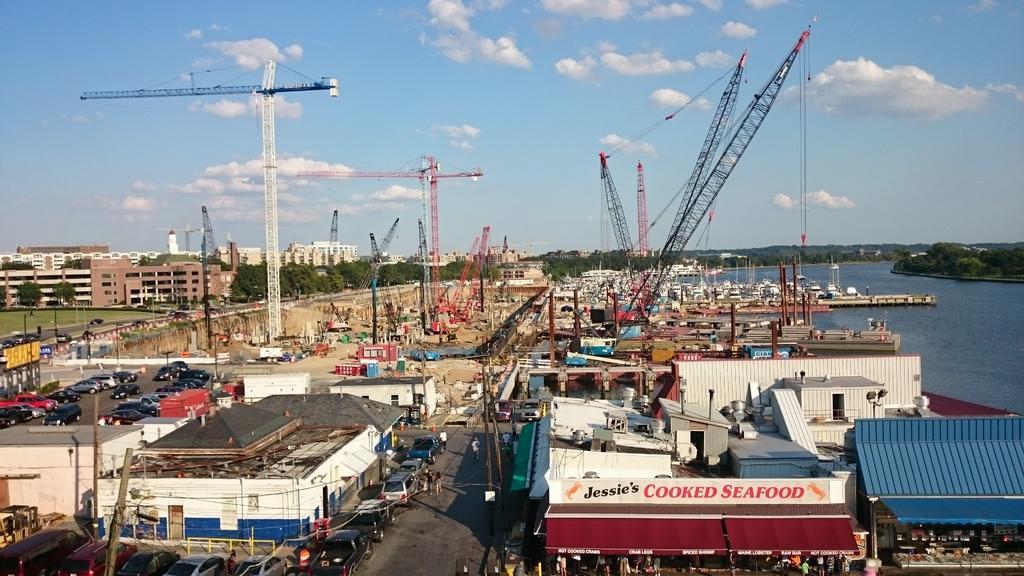How would you summarize this image in a sentence or two? There are many buildings. Also there are many vehicles and tower cranes. In the background there are trees, water and sky with clouds. 